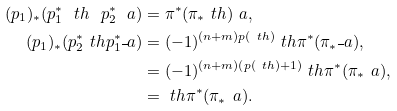Convert formula to latex. <formula><loc_0><loc_0><loc_500><loc_500>( p _ { 1 } ) _ { * } ( p _ { 1 } ^ { * } \ t h \ p _ { 2 } ^ { * } \ a ) & = \pi ^ { * } ( \pi _ { * } \ t h ) \ a , \\ ( p _ { 1 } ) _ { * } ( p _ { 2 } ^ { * } \ t h p _ { 1 } ^ { * } \overline { \ } a ) & = ( - 1 ) ^ { ( n + m ) p ( \ t h ) } \ t h \pi ^ { * } ( \pi _ { * } \overline { \ } a ) , \\ & = ( - 1 ) ^ { ( n + m ) ( p ( \ t h ) + 1 ) } \ t h \pi ^ { * } ( \pi _ { * } \ a ) , \\ & = \ t h \pi ^ { * } ( \pi _ { * } \ a ) .</formula> 